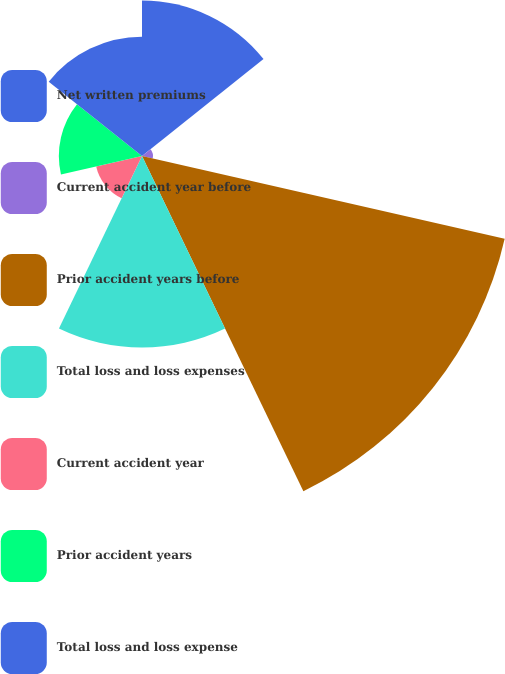<chart> <loc_0><loc_0><loc_500><loc_500><pie_chart><fcel>Net written premiums<fcel>Current accident year before<fcel>Prior accident years before<fcel>Total loss and loss expenses<fcel>Current accident year<fcel>Prior accident years<fcel>Total loss and loss expense<nl><fcel>15.87%<fcel>1.12%<fcel>37.99%<fcel>19.55%<fcel>4.8%<fcel>8.49%<fcel>12.18%<nl></chart> 